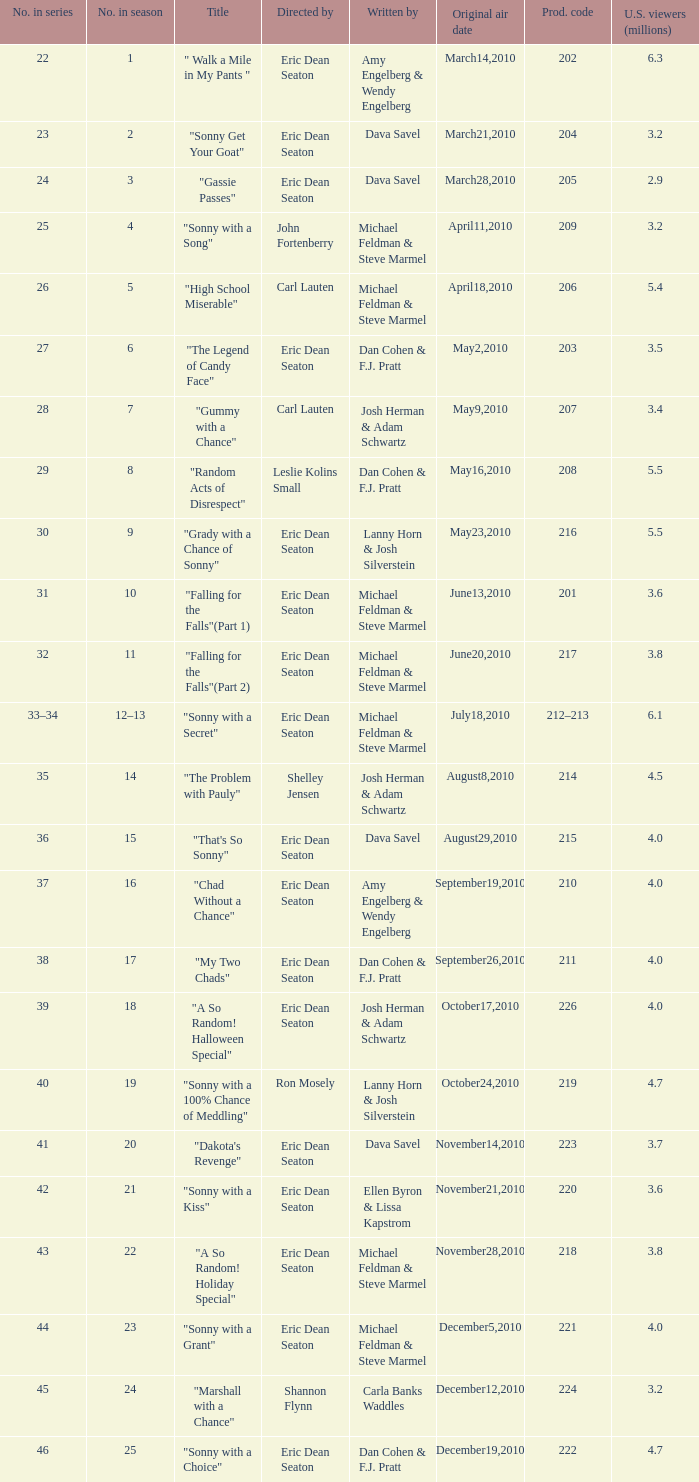In the season, how many episodes were named "that's so sonny"? 1.0. 